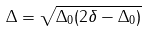<formula> <loc_0><loc_0><loc_500><loc_500>\Delta = \sqrt { \Delta _ { 0 } ( 2 \delta - \Delta _ { 0 } ) }</formula> 